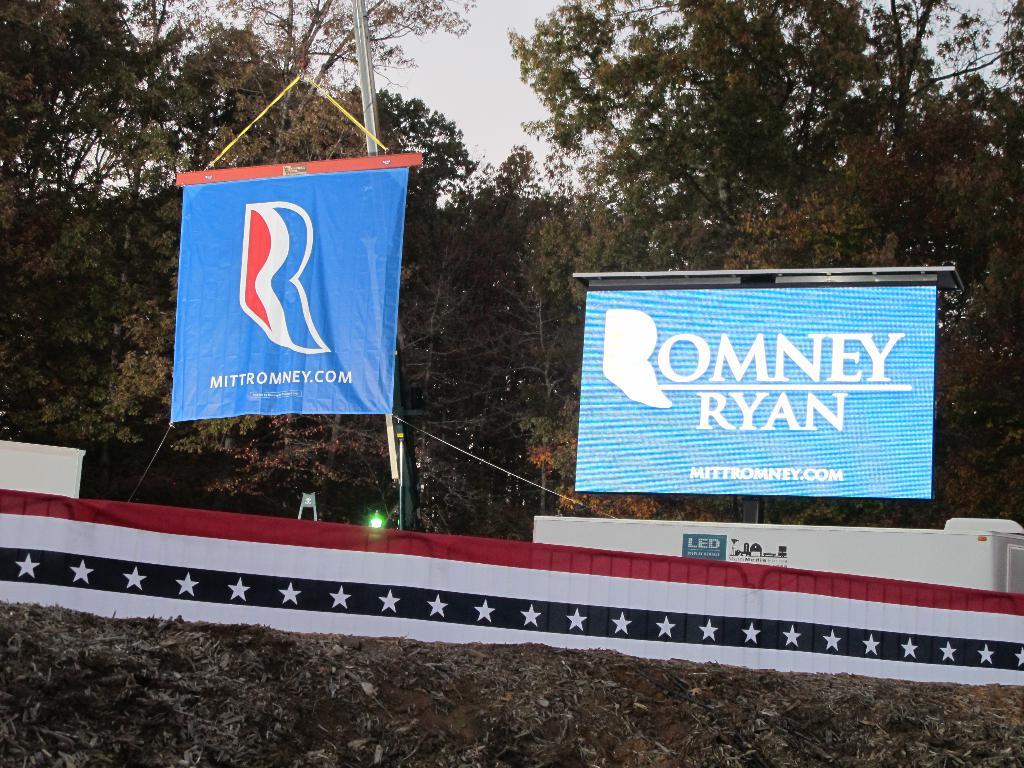What is on the 2 signs?
Provide a short and direct response. Romney ryan. 